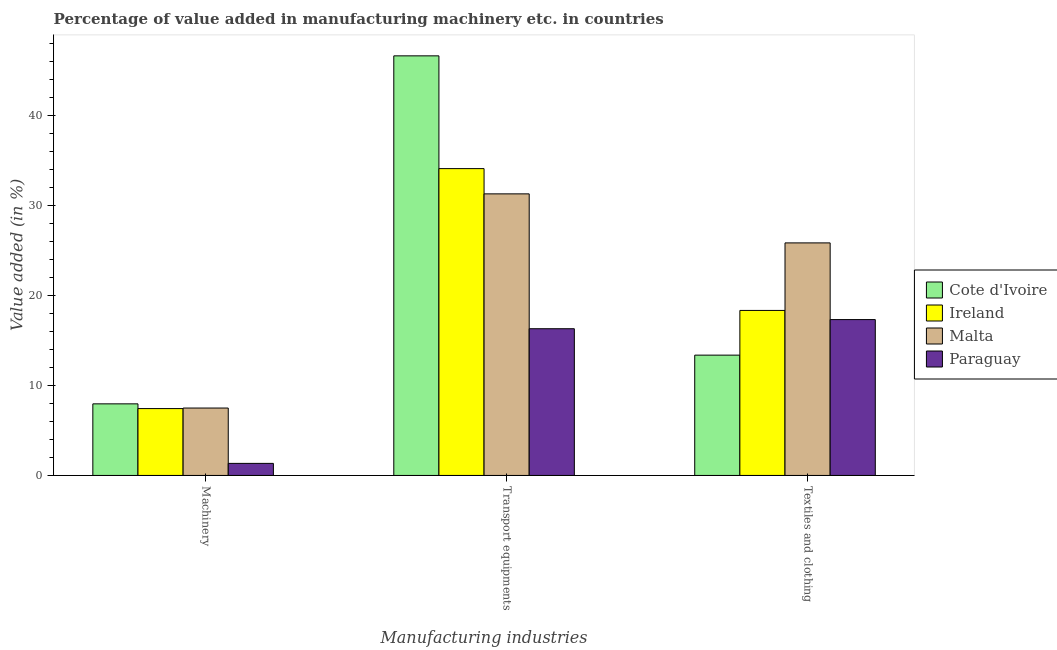How many different coloured bars are there?
Make the answer very short. 4. What is the label of the 1st group of bars from the left?
Ensure brevity in your answer.  Machinery. What is the value added in manufacturing textile and clothing in Cote d'Ivoire?
Your response must be concise. 13.36. Across all countries, what is the maximum value added in manufacturing transport equipments?
Keep it short and to the point. 46.6. Across all countries, what is the minimum value added in manufacturing transport equipments?
Provide a succinct answer. 16.3. In which country was the value added in manufacturing textile and clothing maximum?
Offer a very short reply. Malta. In which country was the value added in manufacturing machinery minimum?
Keep it short and to the point. Paraguay. What is the total value added in manufacturing textile and clothing in the graph?
Keep it short and to the point. 74.83. What is the difference between the value added in manufacturing transport equipments in Ireland and that in Paraguay?
Your answer should be very brief. 17.78. What is the difference between the value added in manufacturing machinery in Cote d'Ivoire and the value added in manufacturing textile and clothing in Ireland?
Your answer should be very brief. -10.38. What is the average value added in manufacturing machinery per country?
Keep it short and to the point. 6.05. What is the difference between the value added in manufacturing transport equipments and value added in manufacturing textile and clothing in Cote d'Ivoire?
Your response must be concise. 33.24. What is the ratio of the value added in manufacturing transport equipments in Paraguay to that in Malta?
Provide a short and direct response. 0.52. Is the difference between the value added in manufacturing transport equipments in Cote d'Ivoire and Ireland greater than the difference between the value added in manufacturing textile and clothing in Cote d'Ivoire and Ireland?
Your answer should be compact. Yes. What is the difference between the highest and the second highest value added in manufacturing textile and clothing?
Your response must be concise. 7.5. What is the difference between the highest and the lowest value added in manufacturing transport equipments?
Your answer should be very brief. 30.31. In how many countries, is the value added in manufacturing textile and clothing greater than the average value added in manufacturing textile and clothing taken over all countries?
Offer a terse response. 1. Is the sum of the value added in manufacturing machinery in Ireland and Paraguay greater than the maximum value added in manufacturing textile and clothing across all countries?
Your response must be concise. No. What does the 1st bar from the left in Machinery represents?
Make the answer very short. Cote d'Ivoire. What does the 1st bar from the right in Textiles and clothing represents?
Give a very brief answer. Paraguay. Is it the case that in every country, the sum of the value added in manufacturing machinery and value added in manufacturing transport equipments is greater than the value added in manufacturing textile and clothing?
Offer a very short reply. Yes. How many bars are there?
Keep it short and to the point. 12. Are all the bars in the graph horizontal?
Keep it short and to the point. No. Are the values on the major ticks of Y-axis written in scientific E-notation?
Provide a short and direct response. No. What is the title of the graph?
Your response must be concise. Percentage of value added in manufacturing machinery etc. in countries. What is the label or title of the X-axis?
Give a very brief answer. Manufacturing industries. What is the label or title of the Y-axis?
Offer a very short reply. Value added (in %). What is the Value added (in %) of Cote d'Ivoire in Machinery?
Your answer should be compact. 7.95. What is the Value added (in %) of Ireland in Machinery?
Provide a short and direct response. 7.42. What is the Value added (in %) in Malta in Machinery?
Offer a terse response. 7.49. What is the Value added (in %) of Paraguay in Machinery?
Offer a very short reply. 1.34. What is the Value added (in %) of Cote d'Ivoire in Transport equipments?
Your response must be concise. 46.6. What is the Value added (in %) in Ireland in Transport equipments?
Offer a terse response. 34.08. What is the Value added (in %) of Malta in Transport equipments?
Give a very brief answer. 31.27. What is the Value added (in %) in Paraguay in Transport equipments?
Offer a very short reply. 16.3. What is the Value added (in %) in Cote d'Ivoire in Textiles and clothing?
Provide a succinct answer. 13.36. What is the Value added (in %) of Ireland in Textiles and clothing?
Offer a very short reply. 18.33. What is the Value added (in %) of Malta in Textiles and clothing?
Provide a short and direct response. 25.83. What is the Value added (in %) in Paraguay in Textiles and clothing?
Keep it short and to the point. 17.31. Across all Manufacturing industries, what is the maximum Value added (in %) in Cote d'Ivoire?
Your response must be concise. 46.6. Across all Manufacturing industries, what is the maximum Value added (in %) in Ireland?
Your response must be concise. 34.08. Across all Manufacturing industries, what is the maximum Value added (in %) of Malta?
Ensure brevity in your answer.  31.27. Across all Manufacturing industries, what is the maximum Value added (in %) of Paraguay?
Your response must be concise. 17.31. Across all Manufacturing industries, what is the minimum Value added (in %) of Cote d'Ivoire?
Your answer should be compact. 7.95. Across all Manufacturing industries, what is the minimum Value added (in %) in Ireland?
Provide a short and direct response. 7.42. Across all Manufacturing industries, what is the minimum Value added (in %) in Malta?
Your response must be concise. 7.49. Across all Manufacturing industries, what is the minimum Value added (in %) of Paraguay?
Keep it short and to the point. 1.34. What is the total Value added (in %) of Cote d'Ivoire in the graph?
Keep it short and to the point. 67.91. What is the total Value added (in %) of Ireland in the graph?
Provide a succinct answer. 59.83. What is the total Value added (in %) in Malta in the graph?
Keep it short and to the point. 64.59. What is the total Value added (in %) of Paraguay in the graph?
Keep it short and to the point. 34.95. What is the difference between the Value added (in %) in Cote d'Ivoire in Machinery and that in Transport equipments?
Provide a succinct answer. -38.65. What is the difference between the Value added (in %) in Ireland in Machinery and that in Transport equipments?
Your response must be concise. -26.65. What is the difference between the Value added (in %) of Malta in Machinery and that in Transport equipments?
Ensure brevity in your answer.  -23.79. What is the difference between the Value added (in %) in Paraguay in Machinery and that in Transport equipments?
Your answer should be very brief. -14.96. What is the difference between the Value added (in %) in Cote d'Ivoire in Machinery and that in Textiles and clothing?
Make the answer very short. -5.41. What is the difference between the Value added (in %) in Ireland in Machinery and that in Textiles and clothing?
Keep it short and to the point. -10.9. What is the difference between the Value added (in %) of Malta in Machinery and that in Textiles and clothing?
Your answer should be compact. -18.34. What is the difference between the Value added (in %) in Paraguay in Machinery and that in Textiles and clothing?
Ensure brevity in your answer.  -15.97. What is the difference between the Value added (in %) of Cote d'Ivoire in Transport equipments and that in Textiles and clothing?
Offer a very short reply. 33.24. What is the difference between the Value added (in %) of Ireland in Transport equipments and that in Textiles and clothing?
Provide a succinct answer. 15.75. What is the difference between the Value added (in %) in Malta in Transport equipments and that in Textiles and clothing?
Give a very brief answer. 5.45. What is the difference between the Value added (in %) of Paraguay in Transport equipments and that in Textiles and clothing?
Offer a terse response. -1.01. What is the difference between the Value added (in %) in Cote d'Ivoire in Machinery and the Value added (in %) in Ireland in Transport equipments?
Give a very brief answer. -26.13. What is the difference between the Value added (in %) in Cote d'Ivoire in Machinery and the Value added (in %) in Malta in Transport equipments?
Your answer should be very brief. -23.32. What is the difference between the Value added (in %) of Cote d'Ivoire in Machinery and the Value added (in %) of Paraguay in Transport equipments?
Offer a terse response. -8.34. What is the difference between the Value added (in %) of Ireland in Machinery and the Value added (in %) of Malta in Transport equipments?
Ensure brevity in your answer.  -23.85. What is the difference between the Value added (in %) in Ireland in Machinery and the Value added (in %) in Paraguay in Transport equipments?
Offer a terse response. -8.87. What is the difference between the Value added (in %) in Malta in Machinery and the Value added (in %) in Paraguay in Transport equipments?
Your response must be concise. -8.81. What is the difference between the Value added (in %) in Cote d'Ivoire in Machinery and the Value added (in %) in Ireland in Textiles and clothing?
Make the answer very short. -10.38. What is the difference between the Value added (in %) of Cote d'Ivoire in Machinery and the Value added (in %) of Malta in Textiles and clothing?
Your answer should be compact. -17.88. What is the difference between the Value added (in %) in Cote d'Ivoire in Machinery and the Value added (in %) in Paraguay in Textiles and clothing?
Offer a very short reply. -9.36. What is the difference between the Value added (in %) in Ireland in Machinery and the Value added (in %) in Malta in Textiles and clothing?
Your answer should be compact. -18.4. What is the difference between the Value added (in %) of Ireland in Machinery and the Value added (in %) of Paraguay in Textiles and clothing?
Make the answer very short. -9.89. What is the difference between the Value added (in %) in Malta in Machinery and the Value added (in %) in Paraguay in Textiles and clothing?
Offer a very short reply. -9.82. What is the difference between the Value added (in %) in Cote d'Ivoire in Transport equipments and the Value added (in %) in Ireland in Textiles and clothing?
Provide a short and direct response. 28.27. What is the difference between the Value added (in %) of Cote d'Ivoire in Transport equipments and the Value added (in %) of Malta in Textiles and clothing?
Offer a terse response. 20.77. What is the difference between the Value added (in %) of Cote d'Ivoire in Transport equipments and the Value added (in %) of Paraguay in Textiles and clothing?
Keep it short and to the point. 29.29. What is the difference between the Value added (in %) in Ireland in Transport equipments and the Value added (in %) in Malta in Textiles and clothing?
Your answer should be very brief. 8.25. What is the difference between the Value added (in %) of Ireland in Transport equipments and the Value added (in %) of Paraguay in Textiles and clothing?
Your response must be concise. 16.77. What is the difference between the Value added (in %) in Malta in Transport equipments and the Value added (in %) in Paraguay in Textiles and clothing?
Your response must be concise. 13.96. What is the average Value added (in %) in Cote d'Ivoire per Manufacturing industries?
Provide a short and direct response. 22.64. What is the average Value added (in %) of Ireland per Manufacturing industries?
Give a very brief answer. 19.94. What is the average Value added (in %) in Malta per Manufacturing industries?
Keep it short and to the point. 21.53. What is the average Value added (in %) in Paraguay per Manufacturing industries?
Your answer should be very brief. 11.65. What is the difference between the Value added (in %) of Cote d'Ivoire and Value added (in %) of Ireland in Machinery?
Keep it short and to the point. 0.53. What is the difference between the Value added (in %) of Cote d'Ivoire and Value added (in %) of Malta in Machinery?
Provide a short and direct response. 0.47. What is the difference between the Value added (in %) in Cote d'Ivoire and Value added (in %) in Paraguay in Machinery?
Your answer should be very brief. 6.61. What is the difference between the Value added (in %) in Ireland and Value added (in %) in Malta in Machinery?
Provide a short and direct response. -0.06. What is the difference between the Value added (in %) in Ireland and Value added (in %) in Paraguay in Machinery?
Your answer should be compact. 6.08. What is the difference between the Value added (in %) of Malta and Value added (in %) of Paraguay in Machinery?
Your response must be concise. 6.15. What is the difference between the Value added (in %) in Cote d'Ivoire and Value added (in %) in Ireland in Transport equipments?
Offer a very short reply. 12.52. What is the difference between the Value added (in %) of Cote d'Ivoire and Value added (in %) of Malta in Transport equipments?
Offer a very short reply. 15.33. What is the difference between the Value added (in %) of Cote d'Ivoire and Value added (in %) of Paraguay in Transport equipments?
Make the answer very short. 30.31. What is the difference between the Value added (in %) in Ireland and Value added (in %) in Malta in Transport equipments?
Provide a short and direct response. 2.8. What is the difference between the Value added (in %) of Ireland and Value added (in %) of Paraguay in Transport equipments?
Give a very brief answer. 17.78. What is the difference between the Value added (in %) of Malta and Value added (in %) of Paraguay in Transport equipments?
Your answer should be compact. 14.98. What is the difference between the Value added (in %) of Cote d'Ivoire and Value added (in %) of Ireland in Textiles and clothing?
Your answer should be very brief. -4.96. What is the difference between the Value added (in %) of Cote d'Ivoire and Value added (in %) of Malta in Textiles and clothing?
Your answer should be very brief. -12.47. What is the difference between the Value added (in %) in Cote d'Ivoire and Value added (in %) in Paraguay in Textiles and clothing?
Offer a very short reply. -3.95. What is the difference between the Value added (in %) of Ireland and Value added (in %) of Malta in Textiles and clothing?
Your answer should be compact. -7.5. What is the difference between the Value added (in %) of Ireland and Value added (in %) of Paraguay in Textiles and clothing?
Your answer should be very brief. 1.02. What is the difference between the Value added (in %) in Malta and Value added (in %) in Paraguay in Textiles and clothing?
Your answer should be very brief. 8.52. What is the ratio of the Value added (in %) in Cote d'Ivoire in Machinery to that in Transport equipments?
Offer a terse response. 0.17. What is the ratio of the Value added (in %) in Ireland in Machinery to that in Transport equipments?
Provide a succinct answer. 0.22. What is the ratio of the Value added (in %) in Malta in Machinery to that in Transport equipments?
Give a very brief answer. 0.24. What is the ratio of the Value added (in %) of Paraguay in Machinery to that in Transport equipments?
Your answer should be very brief. 0.08. What is the ratio of the Value added (in %) in Cote d'Ivoire in Machinery to that in Textiles and clothing?
Provide a short and direct response. 0.6. What is the ratio of the Value added (in %) in Ireland in Machinery to that in Textiles and clothing?
Ensure brevity in your answer.  0.41. What is the ratio of the Value added (in %) in Malta in Machinery to that in Textiles and clothing?
Offer a terse response. 0.29. What is the ratio of the Value added (in %) in Paraguay in Machinery to that in Textiles and clothing?
Provide a succinct answer. 0.08. What is the ratio of the Value added (in %) of Cote d'Ivoire in Transport equipments to that in Textiles and clothing?
Provide a short and direct response. 3.49. What is the ratio of the Value added (in %) in Ireland in Transport equipments to that in Textiles and clothing?
Offer a terse response. 1.86. What is the ratio of the Value added (in %) of Malta in Transport equipments to that in Textiles and clothing?
Your response must be concise. 1.21. What is the ratio of the Value added (in %) in Paraguay in Transport equipments to that in Textiles and clothing?
Your response must be concise. 0.94. What is the difference between the highest and the second highest Value added (in %) in Cote d'Ivoire?
Make the answer very short. 33.24. What is the difference between the highest and the second highest Value added (in %) of Ireland?
Offer a terse response. 15.75. What is the difference between the highest and the second highest Value added (in %) in Malta?
Offer a terse response. 5.45. What is the difference between the highest and the lowest Value added (in %) of Cote d'Ivoire?
Your answer should be compact. 38.65. What is the difference between the highest and the lowest Value added (in %) in Ireland?
Make the answer very short. 26.65. What is the difference between the highest and the lowest Value added (in %) in Malta?
Your answer should be compact. 23.79. What is the difference between the highest and the lowest Value added (in %) in Paraguay?
Provide a succinct answer. 15.97. 